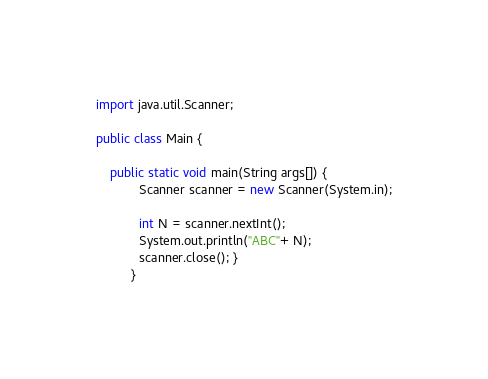<code> <loc_0><loc_0><loc_500><loc_500><_Java_>import java.util.Scanner;

public class Main {
	  
	public static void main(String args[]) {
		    Scanner scanner = new Scanner(System.in);
		    
		    int N = scanner.nextInt();
		    System.out.println("ABC"+ N);
		    scanner.close(); }
		  }</code> 